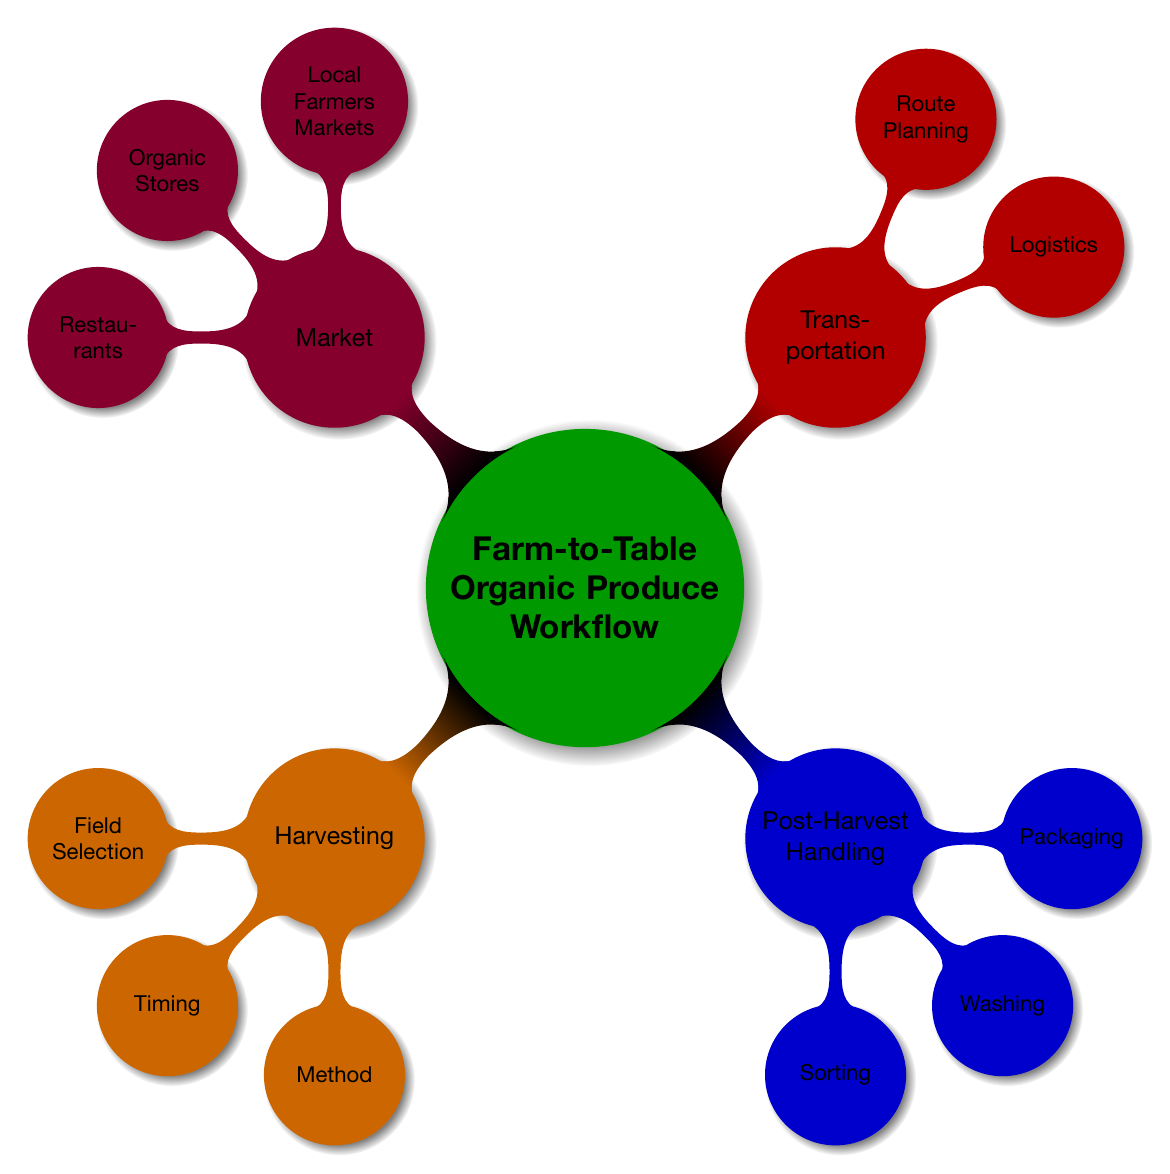What are the three main stages of the farm-to-table workflow? The diagram outlines four primary stages of the farm-to-table workflow: Harvesting, Post-Harvest Handling, Transportation, and Market.
Answer: Harvesting, Post-Harvest Handling, Transportation, Market What is the method used for harvesting? The diagram specifies "Hand Picking" as the method under the Harvesting stage of the workflow.
Answer: Hand Picking What material is used for packaging? According to the Post-Harvest Handling section, "Eco-Friendly Materials" are indicated as the type of packaging used.
Answer: Eco-Friendly Materials How many nodes are in the Market section? The Market section contains three nodes: Local Farmers Markets, Organic Stores, and Restaurants, totaling three nodes.
Answer: 3 What two aspects are considered during Transportation? The Transportation segment highlights two main aspects: Logistics and Route Planning, indicating a focus on these two areas.
Answer: Logistics, Route Planning What does the Sorting node relate to in Post-Harvest Handling? The Sorting node in the Post-Harvest Handling section is directly related to "Quality Control," which clarifies its function.
Answer: Quality Control Which node corresponds with "Optimal Harvest Time"? "Optimal Harvest Time" is specifically linked to the Timing node under the Harvesting stage, clearly indicating its relevance.
Answer: Timing What is the relationship between "Sorting" and "Washing"? Both Sorting and Washing are part of the Post-Harvest Handling stage, indicating that they are sequential steps in the process.
Answer: Part of Post-Harvest Handling What is the main focus of the Harvesting stage? The Harvesting stage primarily focuses on the processes of Field Selection, Timing, and Method, highlighting its comprehensive role in the workflow.
Answer: Field Selection, Timing, Method 